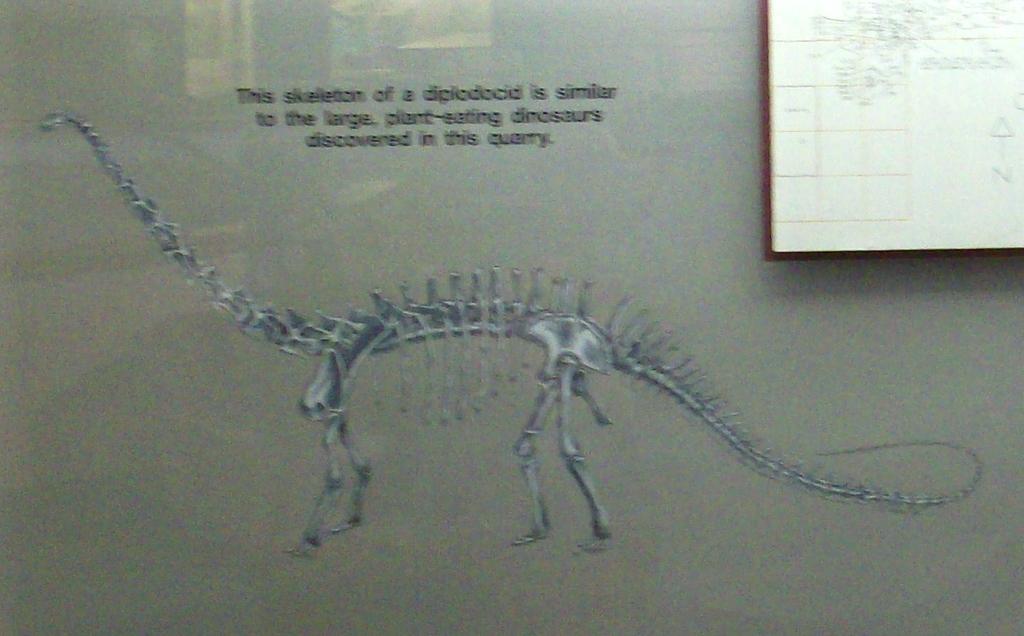What type of dinosaur skeleton is this?
Ensure brevity in your answer.  Diplodocid. Was this discovered in a quarry?
Your answer should be compact. Yes. 